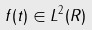<formula> <loc_0><loc_0><loc_500><loc_500>f ( t ) \in L ^ { 2 } ( R )</formula> 